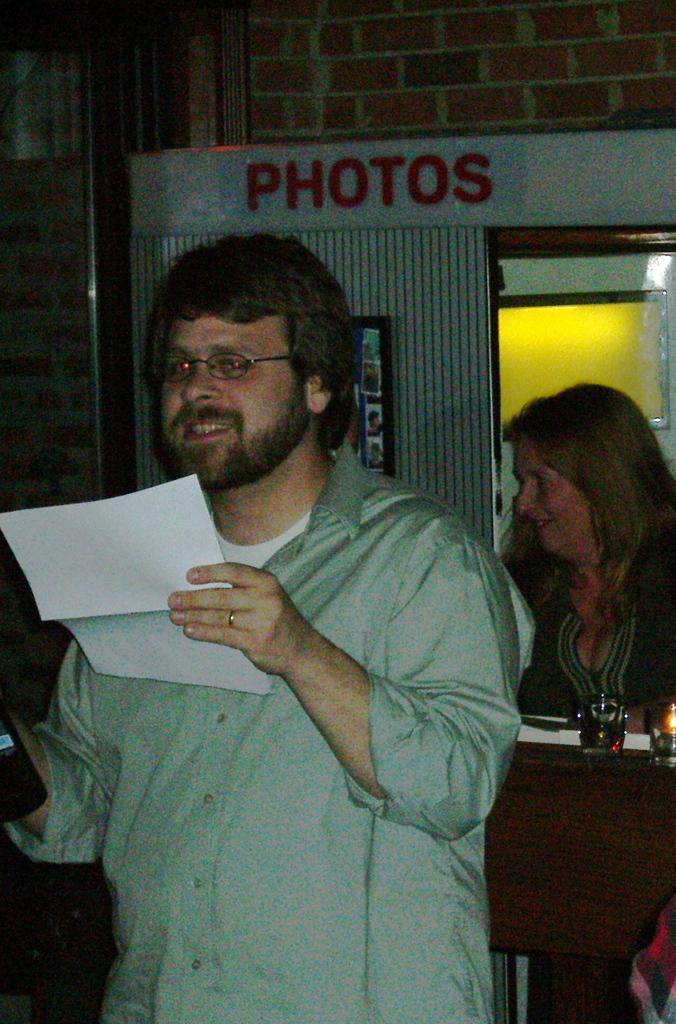How would you summarize this image in a sentence or two? In this image, we can see a person holding a paper and smiling. Background we can see a woman desk, few objects, brick wall and glass object. 